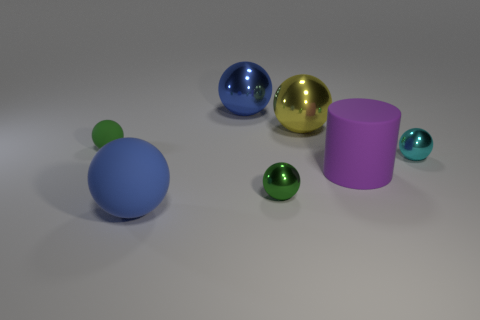How big is the yellow shiny object?
Give a very brief answer. Large. Is the size of the cyan metal object the same as the purple thing?
Ensure brevity in your answer.  No. There is a small thing that is on the right side of the big blue matte ball and to the left of the tiny cyan thing; what color is it?
Give a very brief answer. Green. What number of blue balls have the same material as the small cyan sphere?
Provide a short and direct response. 1. How many big gray matte cylinders are there?
Offer a very short reply. 0. There is a blue metal ball; does it have the same size as the matte thing that is in front of the matte cylinder?
Make the answer very short. Yes. What is the material of the tiny green object that is right of the blue ball in front of the large blue metal ball?
Give a very brief answer. Metal. There is a green ball that is left of the green ball that is in front of the green object that is behind the small cyan metal ball; what is its size?
Keep it short and to the point. Small. There is a blue matte thing; does it have the same shape as the matte object behind the large purple matte cylinder?
Your answer should be very brief. Yes. What is the material of the large yellow thing?
Offer a very short reply. Metal. 